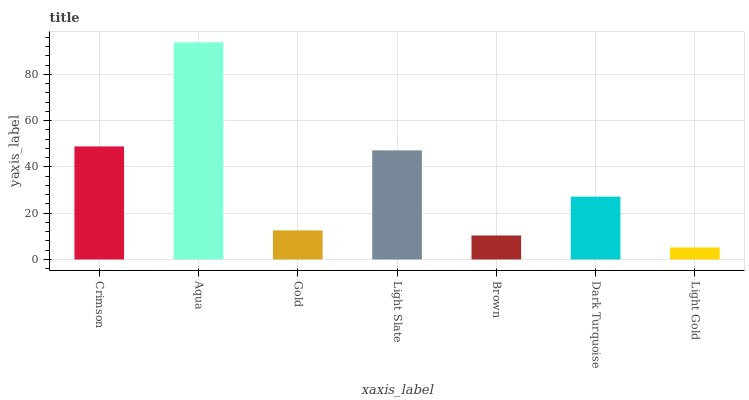Is Light Gold the minimum?
Answer yes or no. Yes. Is Aqua the maximum?
Answer yes or no. Yes. Is Gold the minimum?
Answer yes or no. No. Is Gold the maximum?
Answer yes or no. No. Is Aqua greater than Gold?
Answer yes or no. Yes. Is Gold less than Aqua?
Answer yes or no. Yes. Is Gold greater than Aqua?
Answer yes or no. No. Is Aqua less than Gold?
Answer yes or no. No. Is Dark Turquoise the high median?
Answer yes or no. Yes. Is Dark Turquoise the low median?
Answer yes or no. Yes. Is Aqua the high median?
Answer yes or no. No. Is Gold the low median?
Answer yes or no. No. 